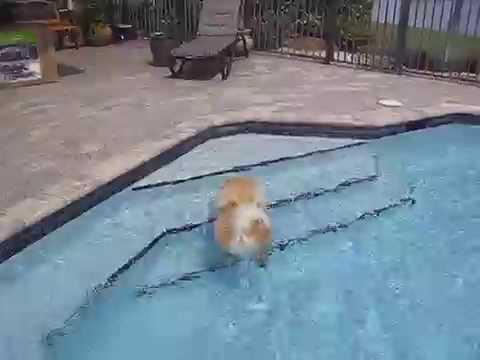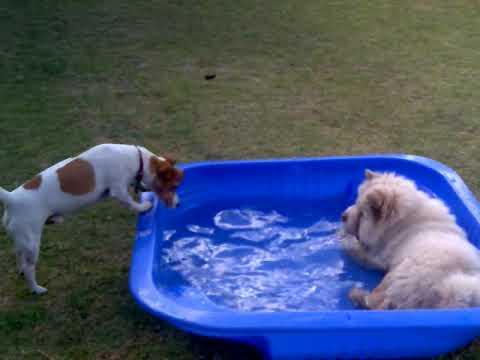The first image is the image on the left, the second image is the image on the right. For the images shown, is this caption "The left image contains exactly two dogs." true? Answer yes or no. No. The first image is the image on the left, the second image is the image on the right. Examine the images to the left and right. Is the description "One dog in the image on the right is standing on a grassy area." accurate? Answer yes or no. Yes. 